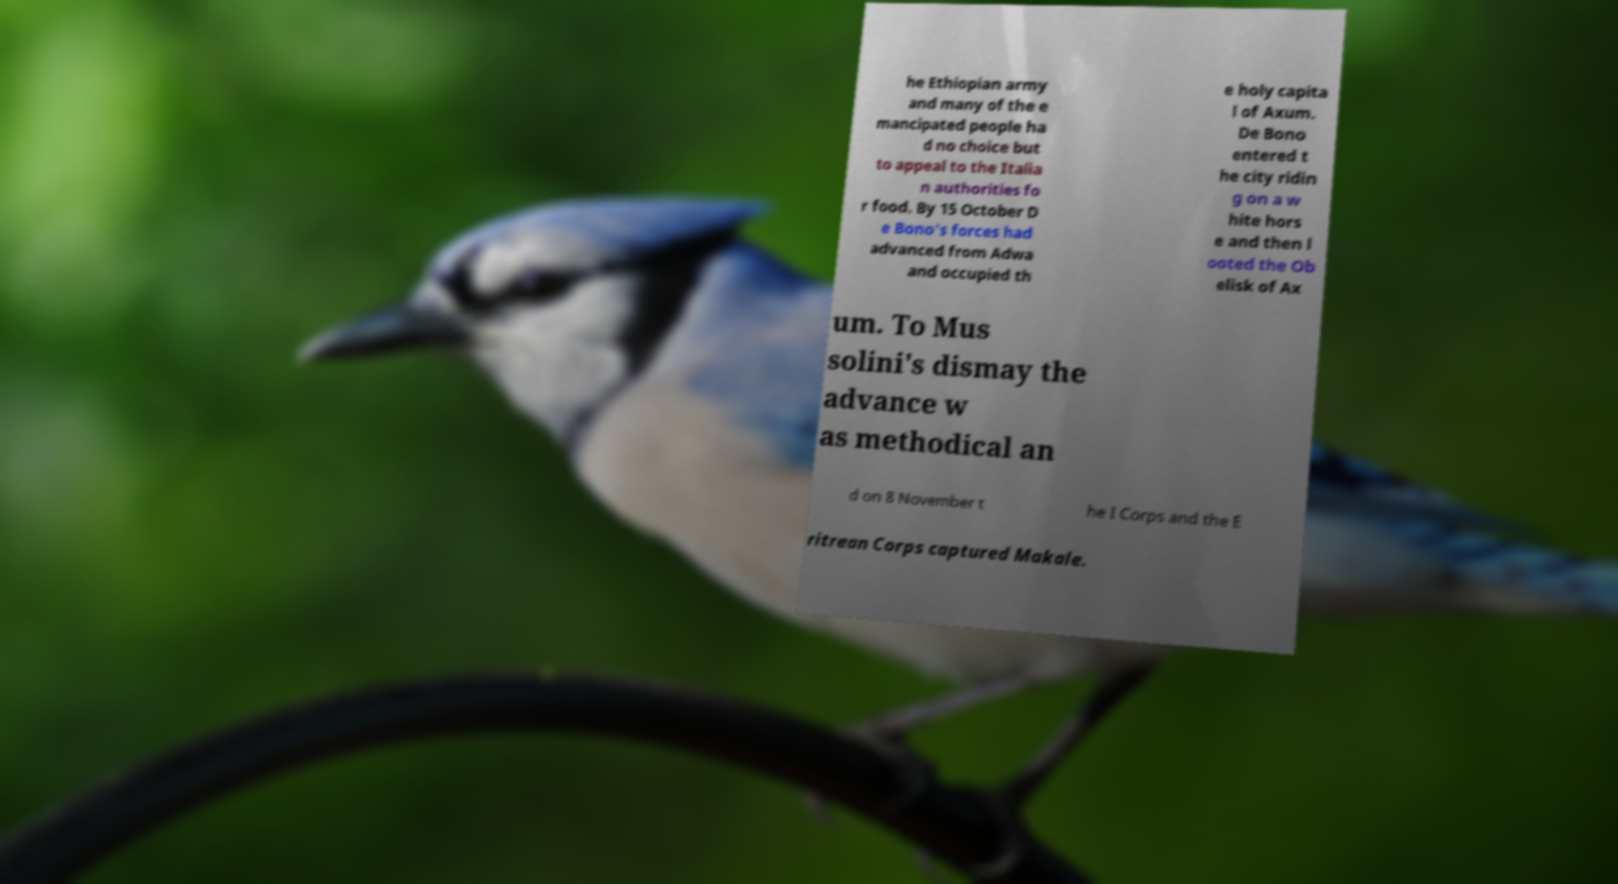Can you read and provide the text displayed in the image?This photo seems to have some interesting text. Can you extract and type it out for me? he Ethiopian army and many of the e mancipated people ha d no choice but to appeal to the Italia n authorities fo r food. By 15 October D e Bono's forces had advanced from Adwa and occupied th e holy capita l of Axum. De Bono entered t he city ridin g on a w hite hors e and then l ooted the Ob elisk of Ax um. To Mus solini's dismay the advance w as methodical an d on 8 November t he I Corps and the E ritrean Corps captured Makale. 